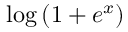<formula> <loc_0><loc_0><loc_500><loc_500>\log \left ( 1 + e ^ { x } \right )</formula> 